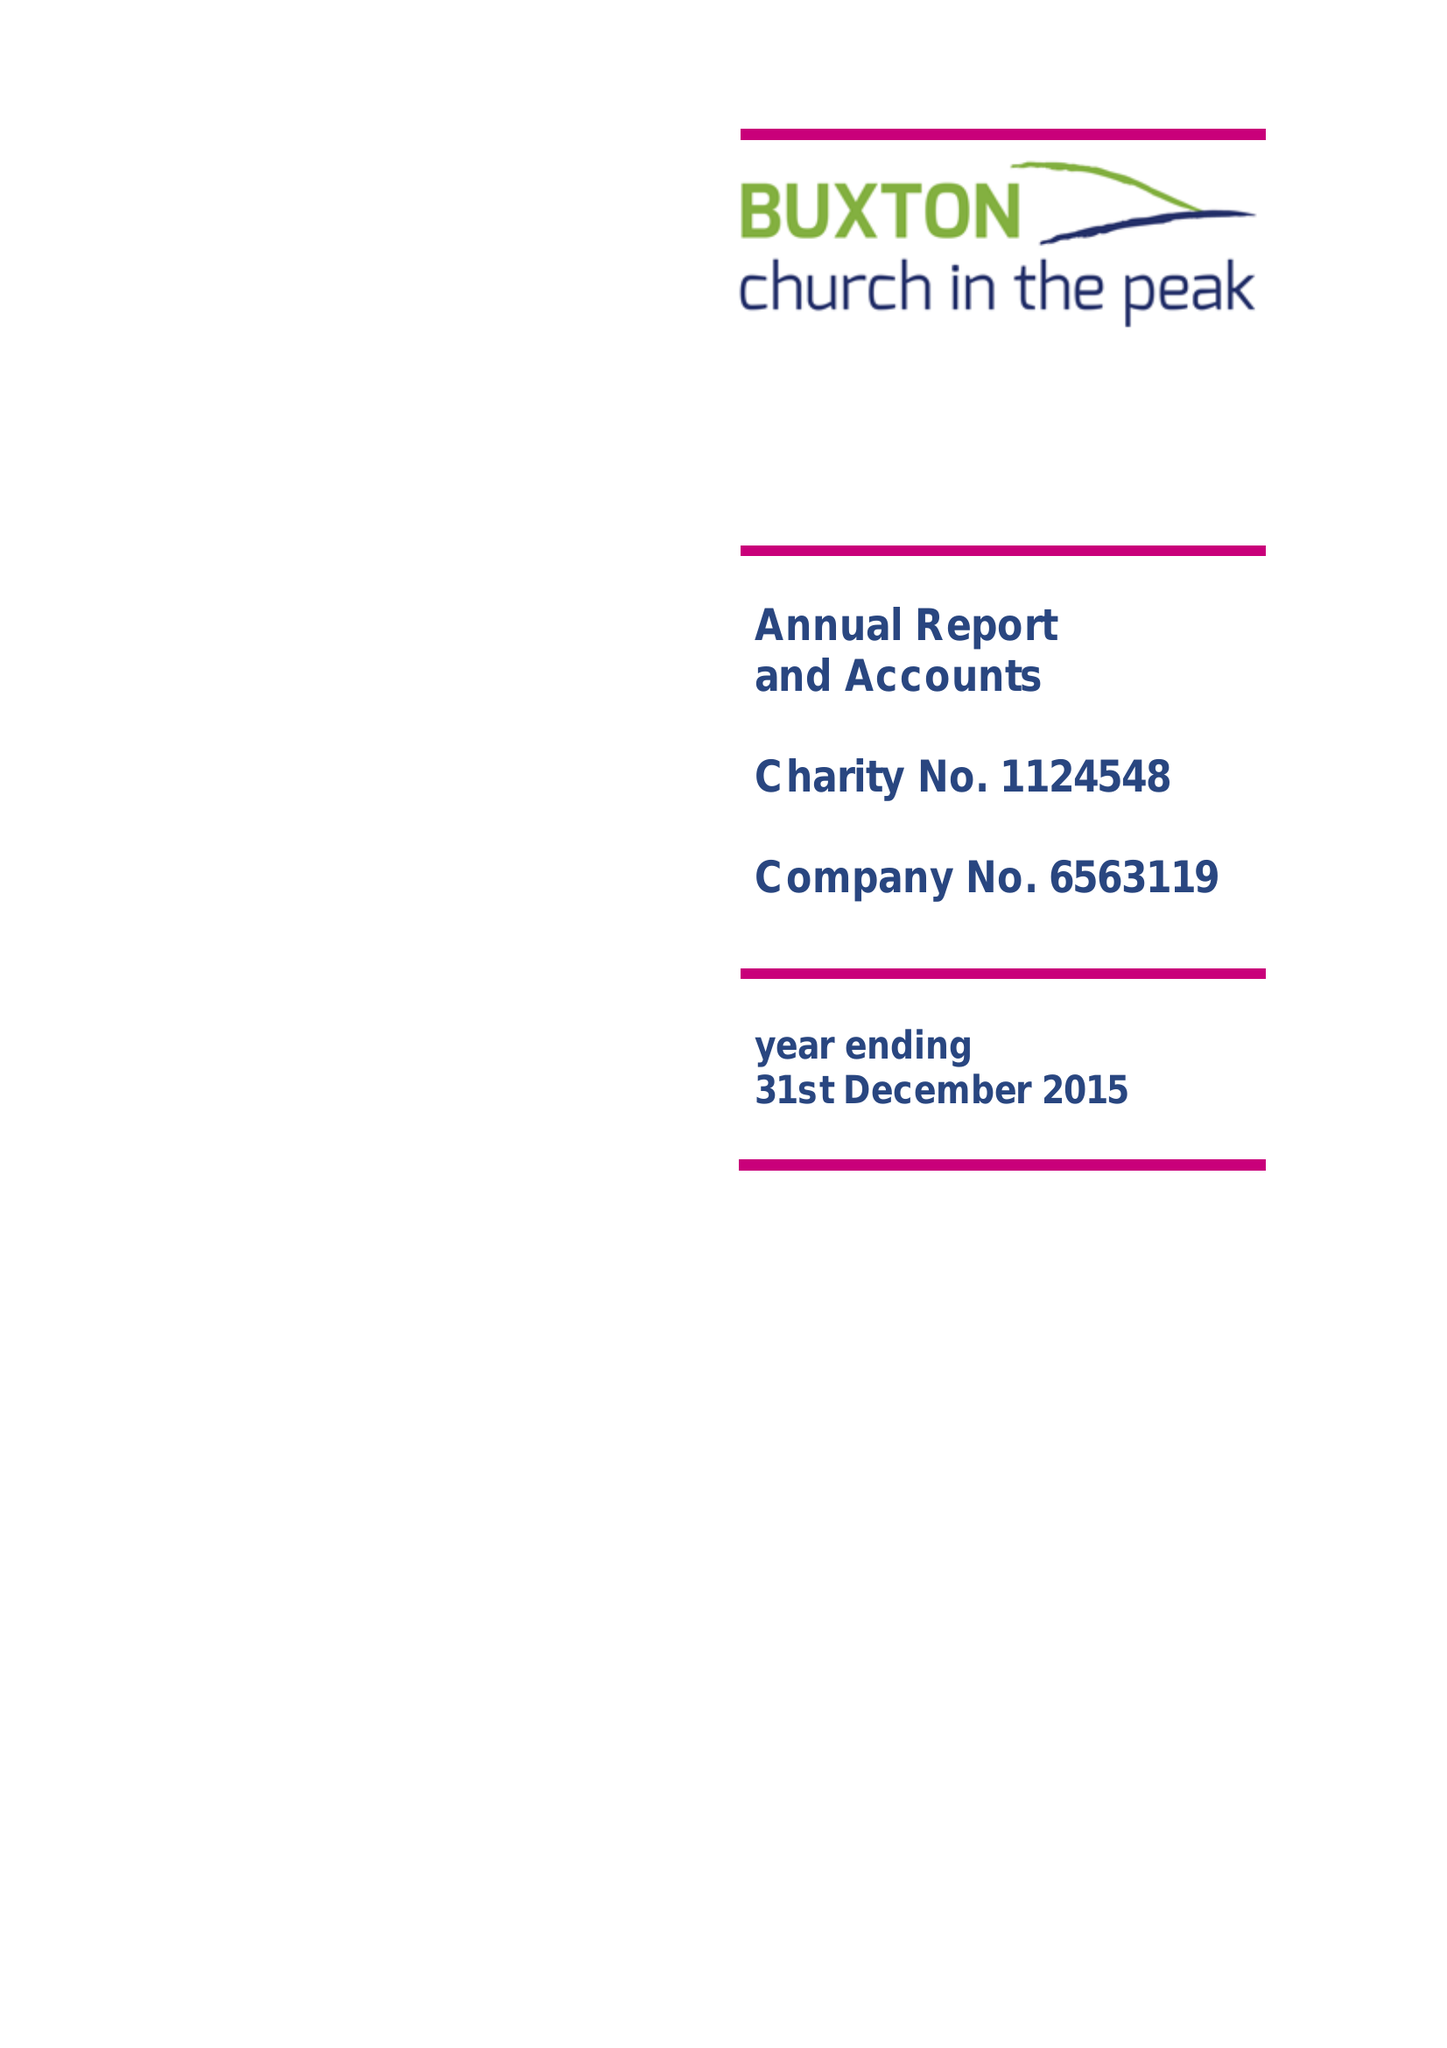What is the value for the spending_annually_in_british_pounds?
Answer the question using a single word or phrase. 108488.00 